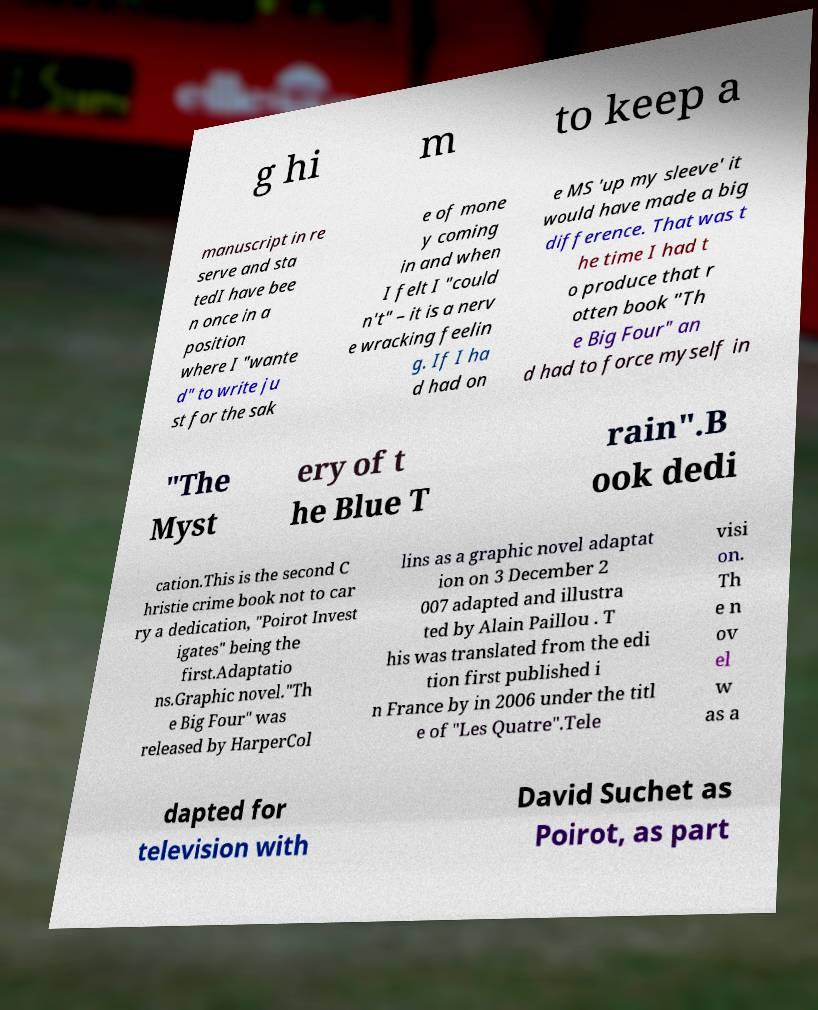Could you extract and type out the text from this image? g hi m to keep a manuscript in re serve and sta tedI have bee n once in a position where I "wante d" to write ju st for the sak e of mone y coming in and when I felt I "could n't" – it is a nerv e wracking feelin g. If I ha d had on e MS 'up my sleeve' it would have made a big difference. That was t he time I had t o produce that r otten book "Th e Big Four" an d had to force myself in "The Myst ery of t he Blue T rain".B ook dedi cation.This is the second C hristie crime book not to car ry a dedication, "Poirot Invest igates" being the first.Adaptatio ns.Graphic novel."Th e Big Four" was released by HarperCol lins as a graphic novel adaptat ion on 3 December 2 007 adapted and illustra ted by Alain Paillou . T his was translated from the edi tion first published i n France by in 2006 under the titl e of "Les Quatre".Tele visi on. Th e n ov el w as a dapted for television with David Suchet as Poirot, as part 